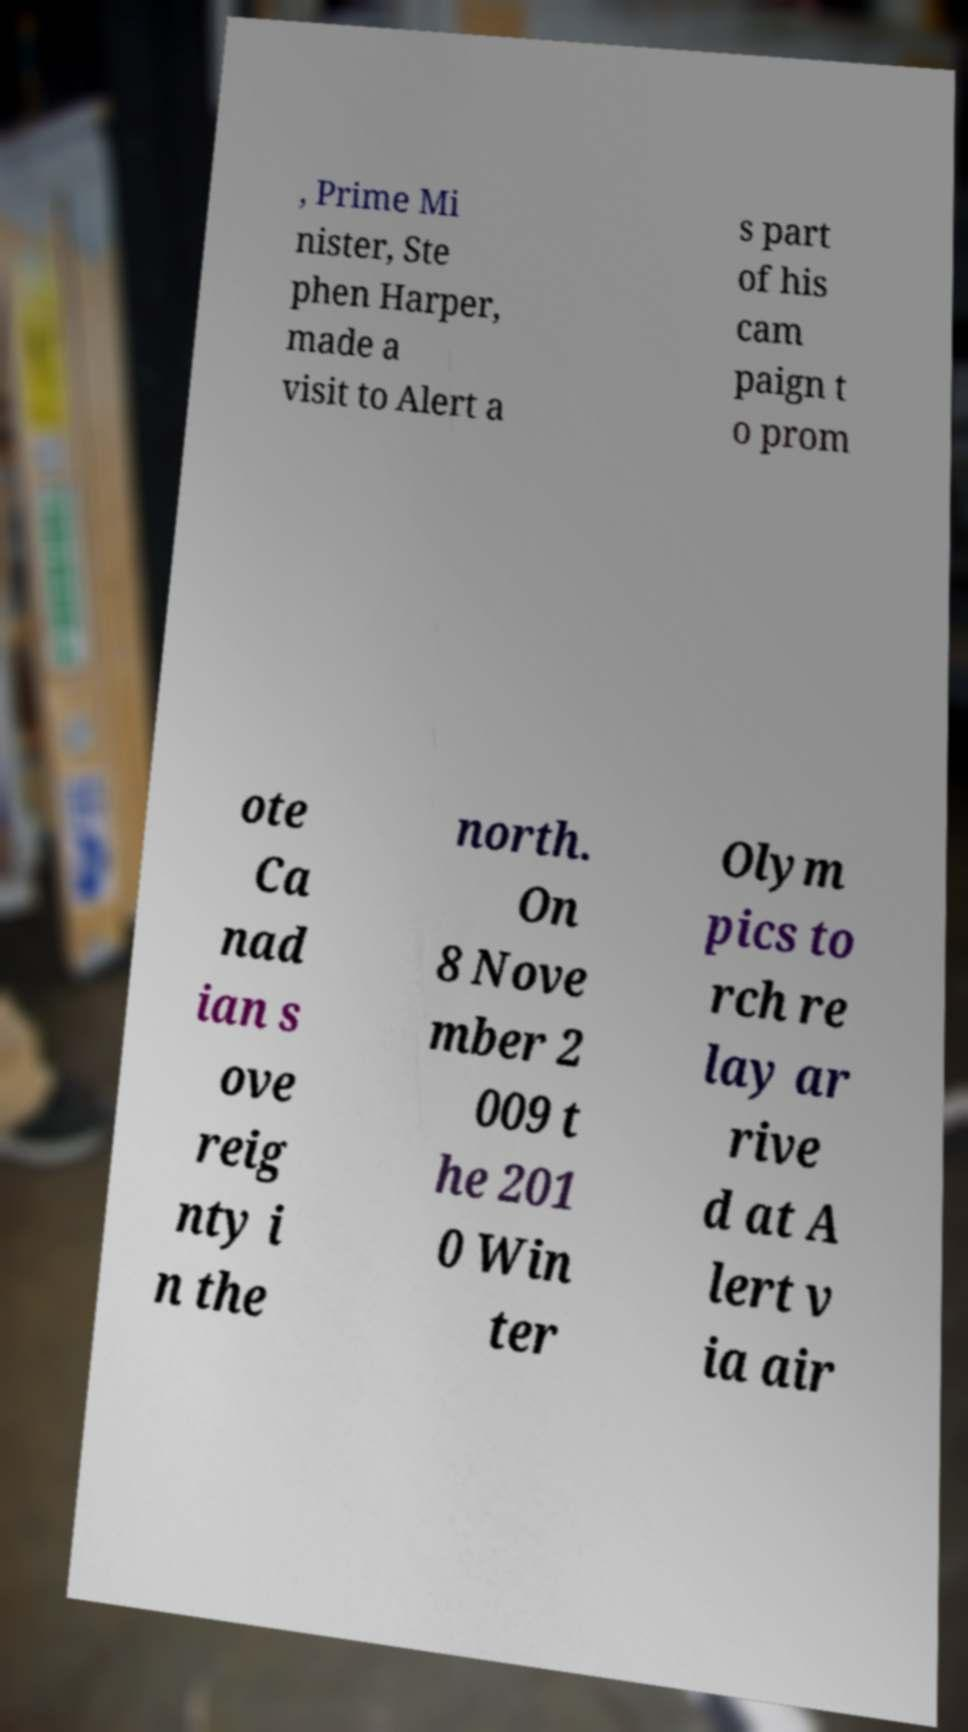Please read and relay the text visible in this image. What does it say? , Prime Mi nister, Ste phen Harper, made a visit to Alert a s part of his cam paign t o prom ote Ca nad ian s ove reig nty i n the north. On 8 Nove mber 2 009 t he 201 0 Win ter Olym pics to rch re lay ar rive d at A lert v ia air 